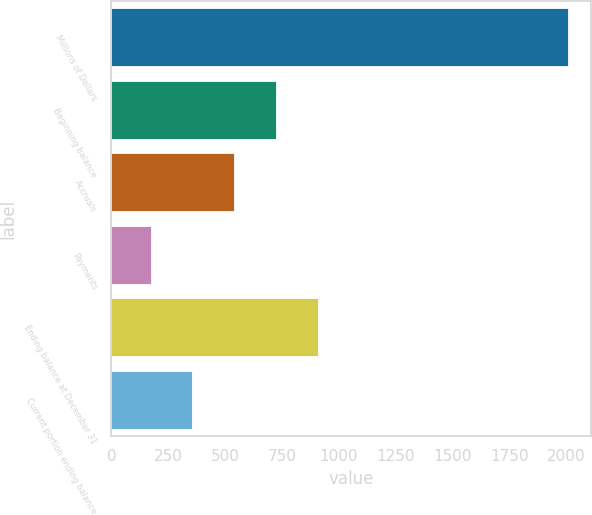Convert chart. <chart><loc_0><loc_0><loc_500><loc_500><bar_chart><fcel>Millions of Dollars<fcel>Beginning balance<fcel>Accruals<fcel>Payments<fcel>Ending balance at December 31<fcel>Current portion ending balance<nl><fcel>2008<fcel>723.5<fcel>540<fcel>173<fcel>907<fcel>356.5<nl></chart> 